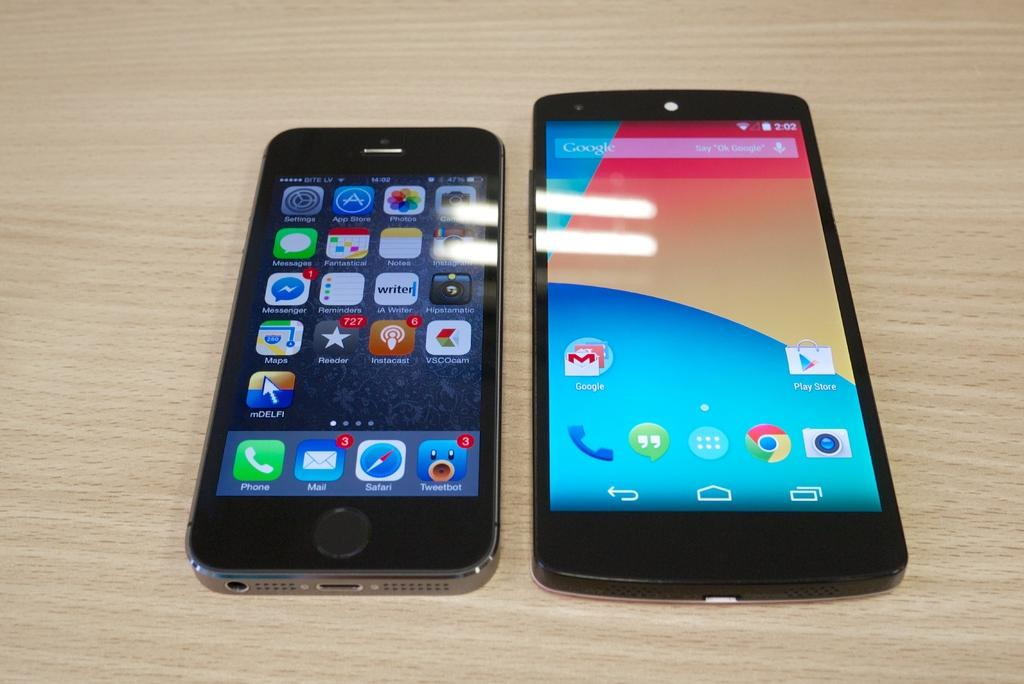<image>
Summarize the visual content of the image. Two phones, one being an iPhone (on the left) and the other being an Android phone (on the right). 